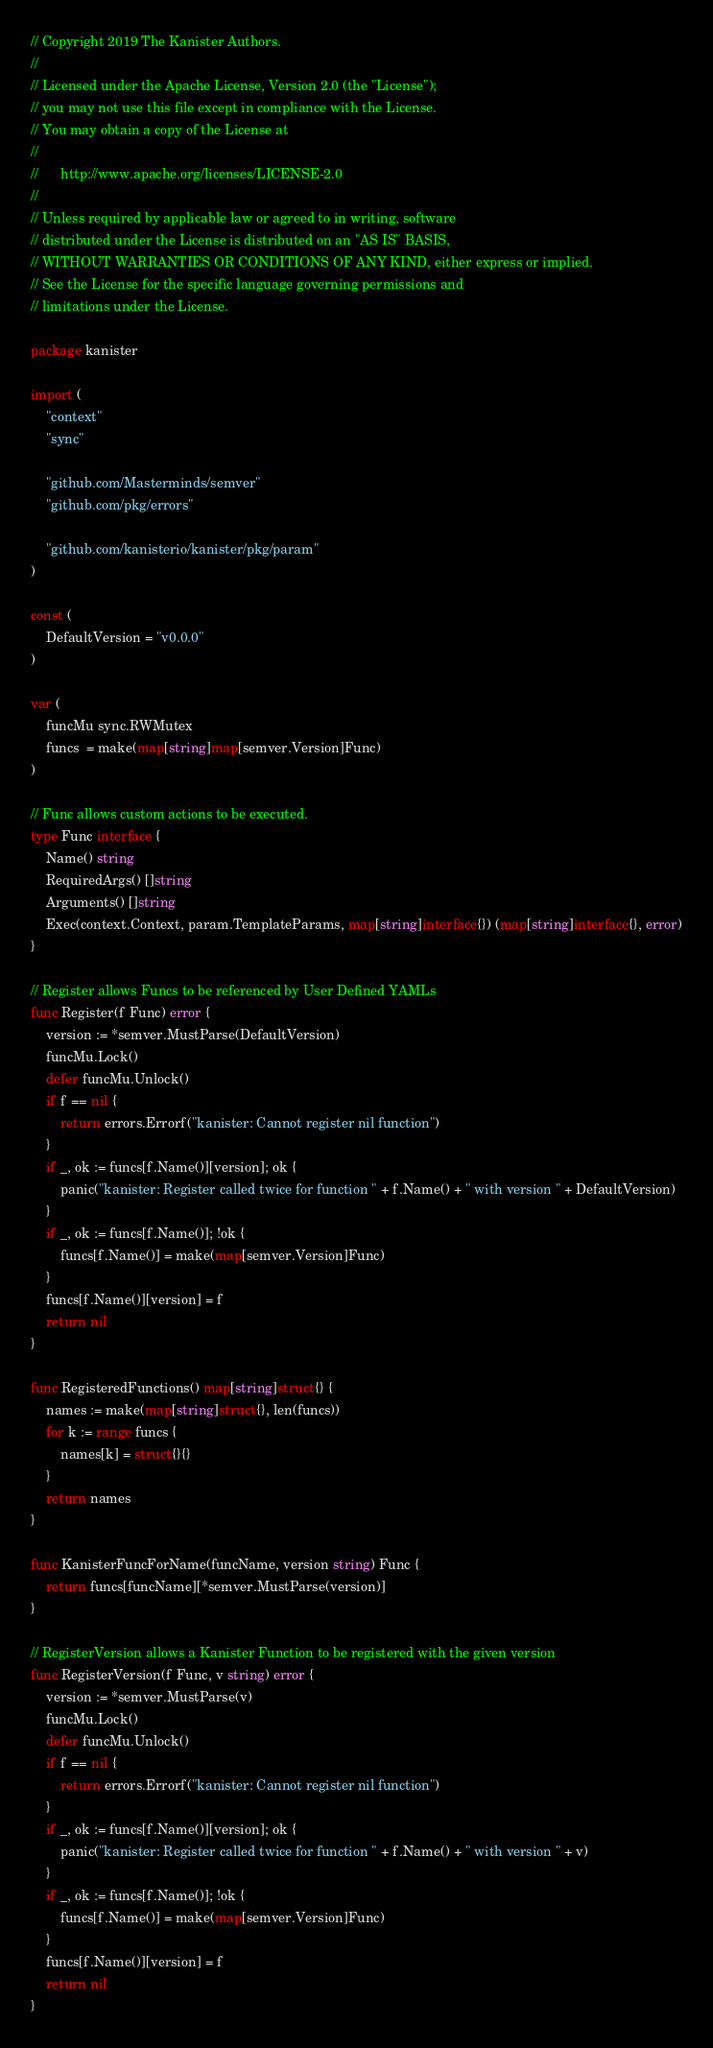<code> <loc_0><loc_0><loc_500><loc_500><_Go_>// Copyright 2019 The Kanister Authors.
//
// Licensed under the Apache License, Version 2.0 (the "License");
// you may not use this file except in compliance with the License.
// You may obtain a copy of the License at
//
//      http://www.apache.org/licenses/LICENSE-2.0
//
// Unless required by applicable law or agreed to in writing, software
// distributed under the License is distributed on an "AS IS" BASIS,
// WITHOUT WARRANTIES OR CONDITIONS OF ANY KIND, either express or implied.
// See the License for the specific language governing permissions and
// limitations under the License.

package kanister

import (
	"context"
	"sync"

	"github.com/Masterminds/semver"
	"github.com/pkg/errors"

	"github.com/kanisterio/kanister/pkg/param"
)

const (
	DefaultVersion = "v0.0.0"
)

var (
	funcMu sync.RWMutex
	funcs  = make(map[string]map[semver.Version]Func)
)

// Func allows custom actions to be executed.
type Func interface {
	Name() string
	RequiredArgs() []string
	Arguments() []string
	Exec(context.Context, param.TemplateParams, map[string]interface{}) (map[string]interface{}, error)
}

// Register allows Funcs to be referenced by User Defined YAMLs
func Register(f Func) error {
	version := *semver.MustParse(DefaultVersion)
	funcMu.Lock()
	defer funcMu.Unlock()
	if f == nil {
		return errors.Errorf("kanister: Cannot register nil function")
	}
	if _, ok := funcs[f.Name()][version]; ok {
		panic("kanister: Register called twice for function " + f.Name() + " with version " + DefaultVersion)
	}
	if _, ok := funcs[f.Name()]; !ok {
		funcs[f.Name()] = make(map[semver.Version]Func)
	}
	funcs[f.Name()][version] = f
	return nil
}

func RegisteredFunctions() map[string]struct{} {
	names := make(map[string]struct{}, len(funcs))
	for k := range funcs {
		names[k] = struct{}{}
	}
	return names
}

func KanisterFuncForName(funcName, version string) Func {
	return funcs[funcName][*semver.MustParse(version)]
}

// RegisterVersion allows a Kanister Function to be registered with the given version
func RegisterVersion(f Func, v string) error {
	version := *semver.MustParse(v)
	funcMu.Lock()
	defer funcMu.Unlock()
	if f == nil {
		return errors.Errorf("kanister: Cannot register nil function")
	}
	if _, ok := funcs[f.Name()][version]; ok {
		panic("kanister: Register called twice for function " + f.Name() + " with version " + v)
	}
	if _, ok := funcs[f.Name()]; !ok {
		funcs[f.Name()] = make(map[semver.Version]Func)
	}
	funcs[f.Name()][version] = f
	return nil
}
</code> 